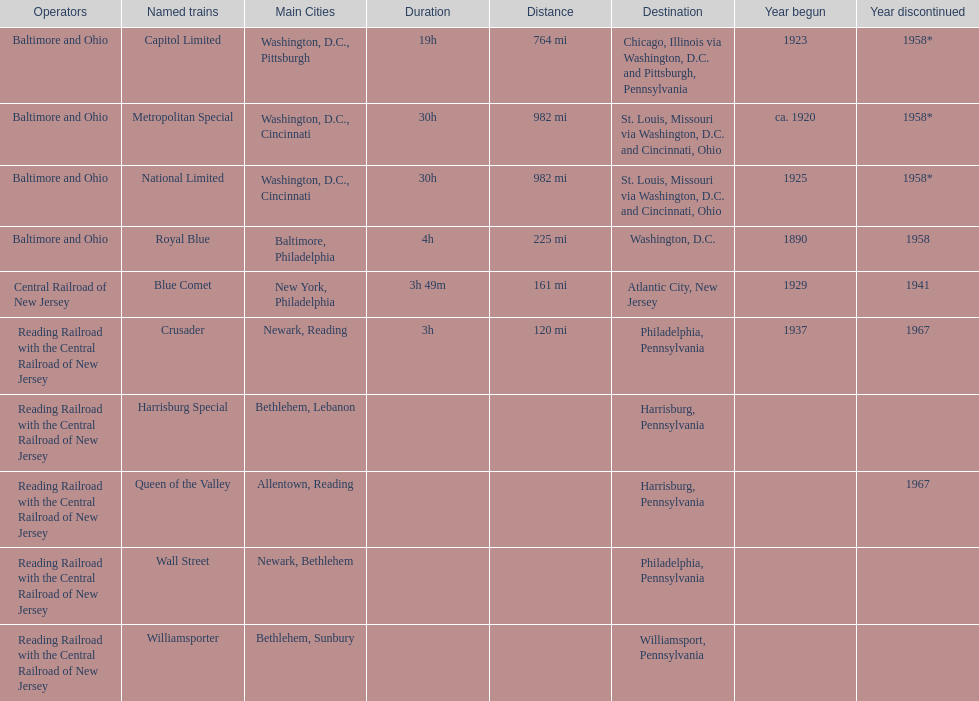Help me parse the entirety of this table. {'header': ['Operators', 'Named trains', 'Main Cities', 'Duration', 'Distance', 'Destination', 'Year begun', 'Year discontinued'], 'rows': [['Baltimore and Ohio', 'Capitol Limited', 'Washington, D.C., Pittsburgh', '19h', '764 mi', 'Chicago, Illinois via Washington, D.C. and Pittsburgh, Pennsylvania', '1923', '1958*'], ['Baltimore and Ohio', 'Metropolitan Special', 'Washington, D.C., Cincinnati', '30h', '982 mi', 'St. Louis, Missouri via Washington, D.C. and Cincinnati, Ohio', 'ca. 1920', '1958*'], ['Baltimore and Ohio', 'National Limited', 'Washington, D.C., Cincinnati', '30h', '982 mi', 'St. Louis, Missouri via Washington, D.C. and Cincinnati, Ohio', '1925', '1958*'], ['Baltimore and Ohio', 'Royal Blue', 'Baltimore, Philadelphia', '4h', '225 mi', 'Washington, D.C.', '1890', '1958'], ['Central Railroad of New Jersey', 'Blue Comet', 'New York, Philadelphia', '3h 49m', '161 mi', 'Atlantic City, New Jersey', '1929', '1941'], ['Reading Railroad with the Central Railroad of New Jersey', 'Crusader', 'Newark, Reading', '3h', '120 mi', 'Philadelphia, Pennsylvania', '1937', '1967'], ['Reading Railroad with the Central Railroad of New Jersey', 'Harrisburg Special', 'Bethlehem, Lebanon', '', '', 'Harrisburg, Pennsylvania', '', ''], ['Reading Railroad with the Central Railroad of New Jersey', 'Queen of the Valley', 'Allentown, Reading', '', '', 'Harrisburg, Pennsylvania', '', '1967'], ['Reading Railroad with the Central Railroad of New Jersey', 'Wall Street', 'Newark, Bethlehem', '', '', 'Philadelphia, Pennsylvania', '', ''], ['Reading Railroad with the Central Railroad of New Jersey', 'Williamsporter', 'Bethlehem, Sunbury', '', '', 'Williamsport, Pennsylvania', '', '']]} What destination is at the top of the list? Chicago, Illinois via Washington, D.C. and Pittsburgh, Pennsylvania. 